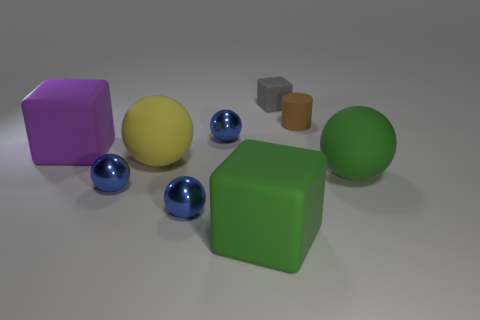Can you tell me which objects are spheres and describe their colors? Certainly. There are three spherical objects in the image, and they are quite easy to spot due to their perfectly round shape. Two of them are smaller and share a deep blue color, positioned near the foreground. The third sphere is larger and green, located more centrally among the objects. 